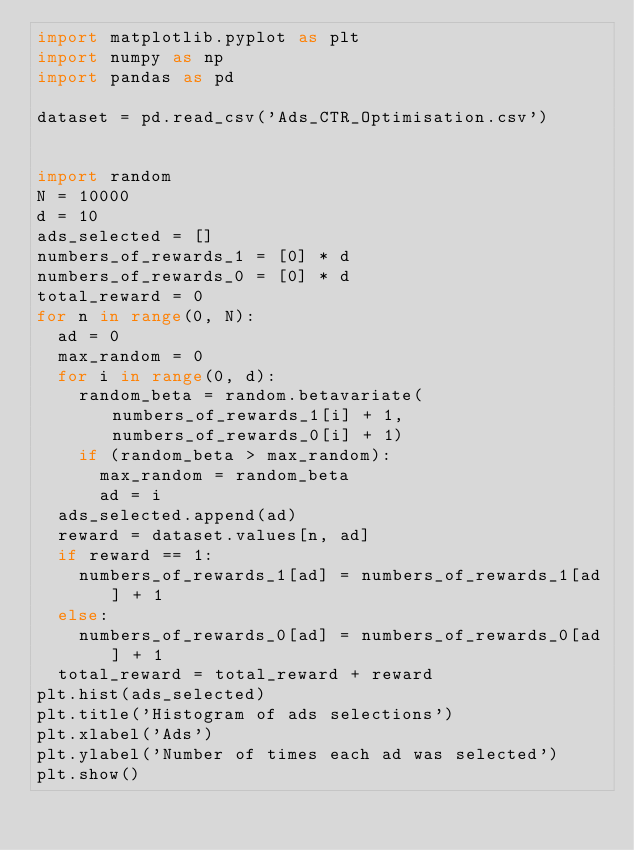Convert code to text. <code><loc_0><loc_0><loc_500><loc_500><_Python_>import matplotlib.pyplot as plt
import numpy as np
import pandas as pd

dataset = pd.read_csv('Ads_CTR_Optimisation.csv')


import random
N = 10000
d = 10
ads_selected = []
numbers_of_rewards_1 = [0] * d
numbers_of_rewards_0 = [0] * d
total_reward = 0
for n in range(0, N):
  ad = 0
  max_random = 0
  for i in range(0, d):
    random_beta = random.betavariate(numbers_of_rewards_1[i] + 1, numbers_of_rewards_0[i] + 1)
    if (random_beta > max_random):
      max_random = random_beta
      ad = i
  ads_selected.append(ad)
  reward = dataset.values[n, ad]
  if reward == 1:
    numbers_of_rewards_1[ad] = numbers_of_rewards_1[ad] + 1
  else:
    numbers_of_rewards_0[ad] = numbers_of_rewards_0[ad] + 1
  total_reward = total_reward + reward
plt.hist(ads_selected)
plt.title('Histogram of ads selections')
plt.xlabel('Ads')
plt.ylabel('Number of times each ad was selected')
plt.show()
</code> 